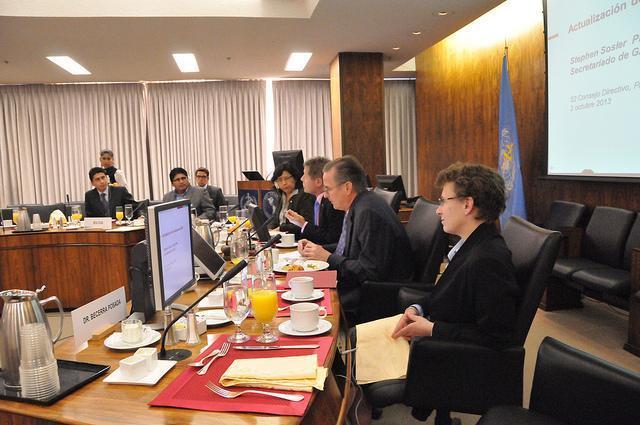How many people are in this picture?
Give a very brief answer. 8. How many chairs are there?
Give a very brief answer. 5. How many people can you see?
Give a very brief answer. 3. How many tvs are in the picture?
Give a very brief answer. 2. 